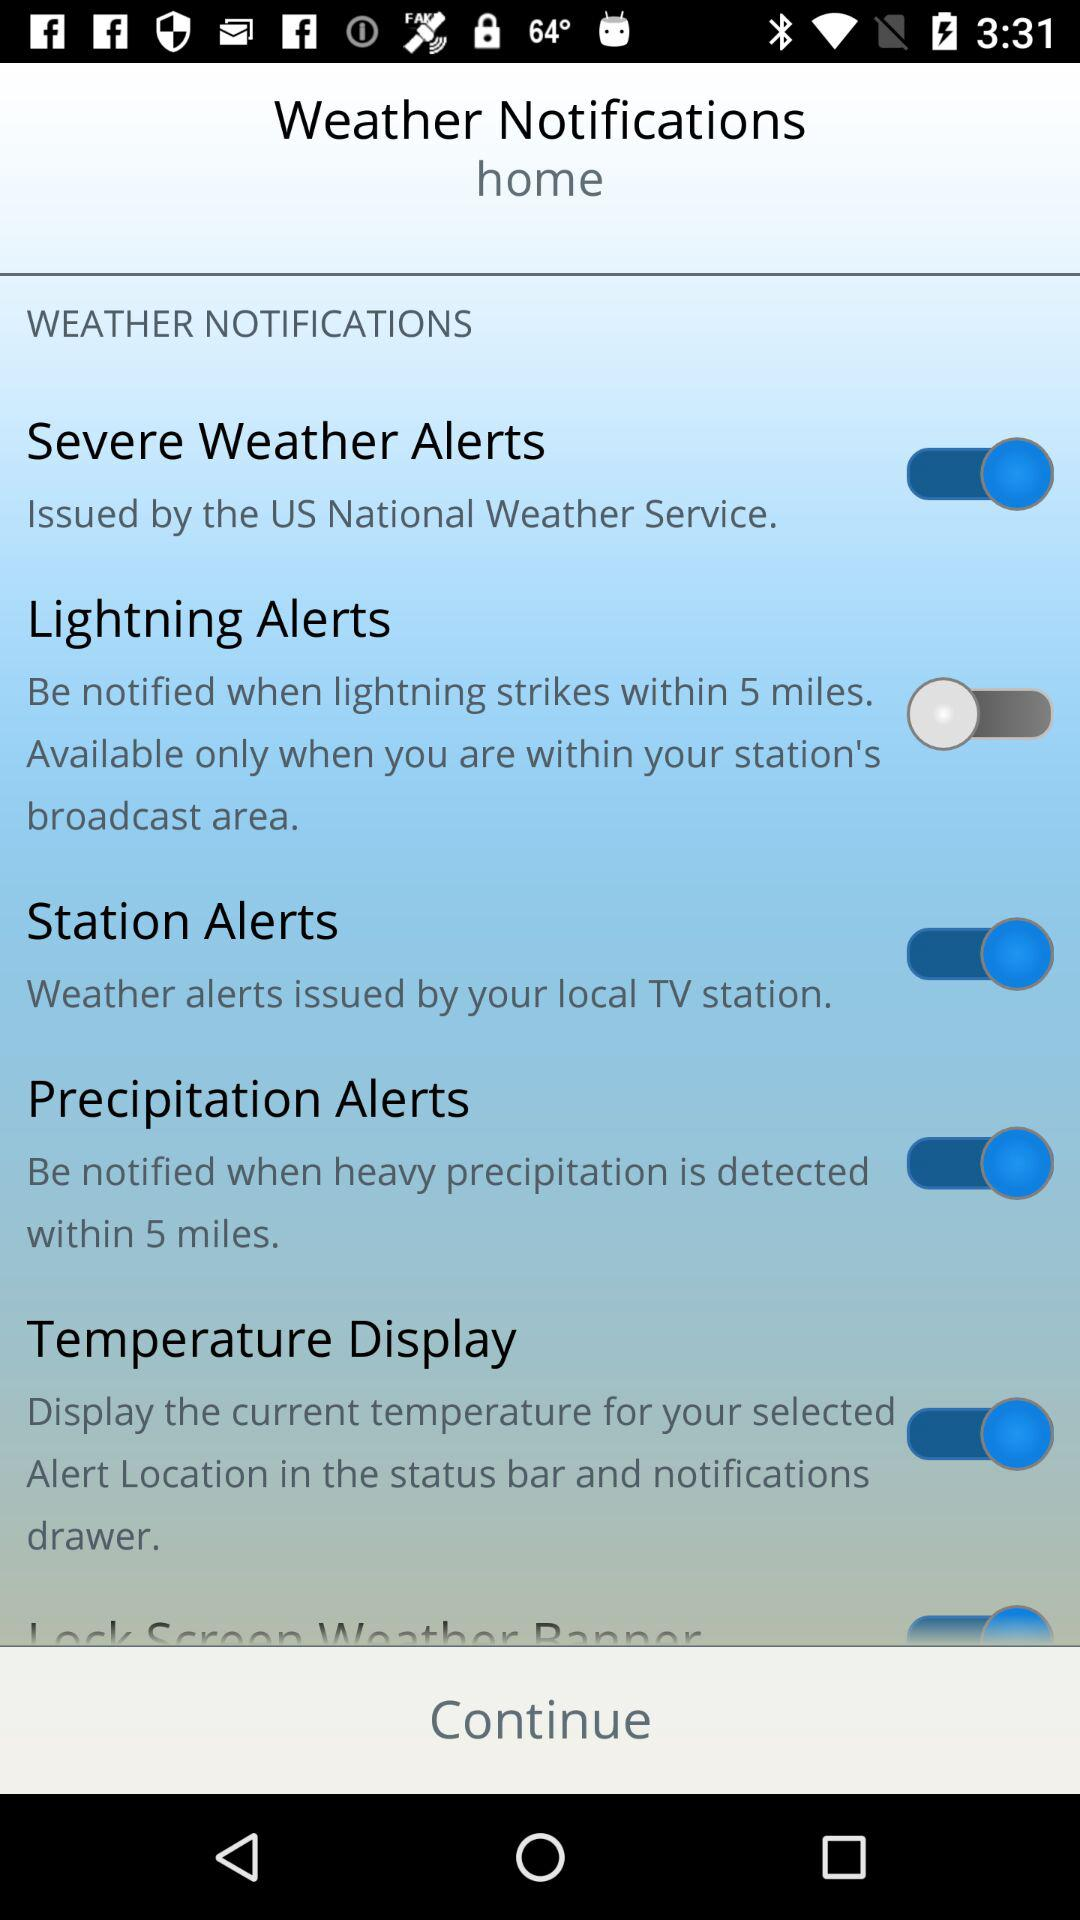In which city is "home" located?
When the provided information is insufficient, respond with <no answer>. <no answer> 